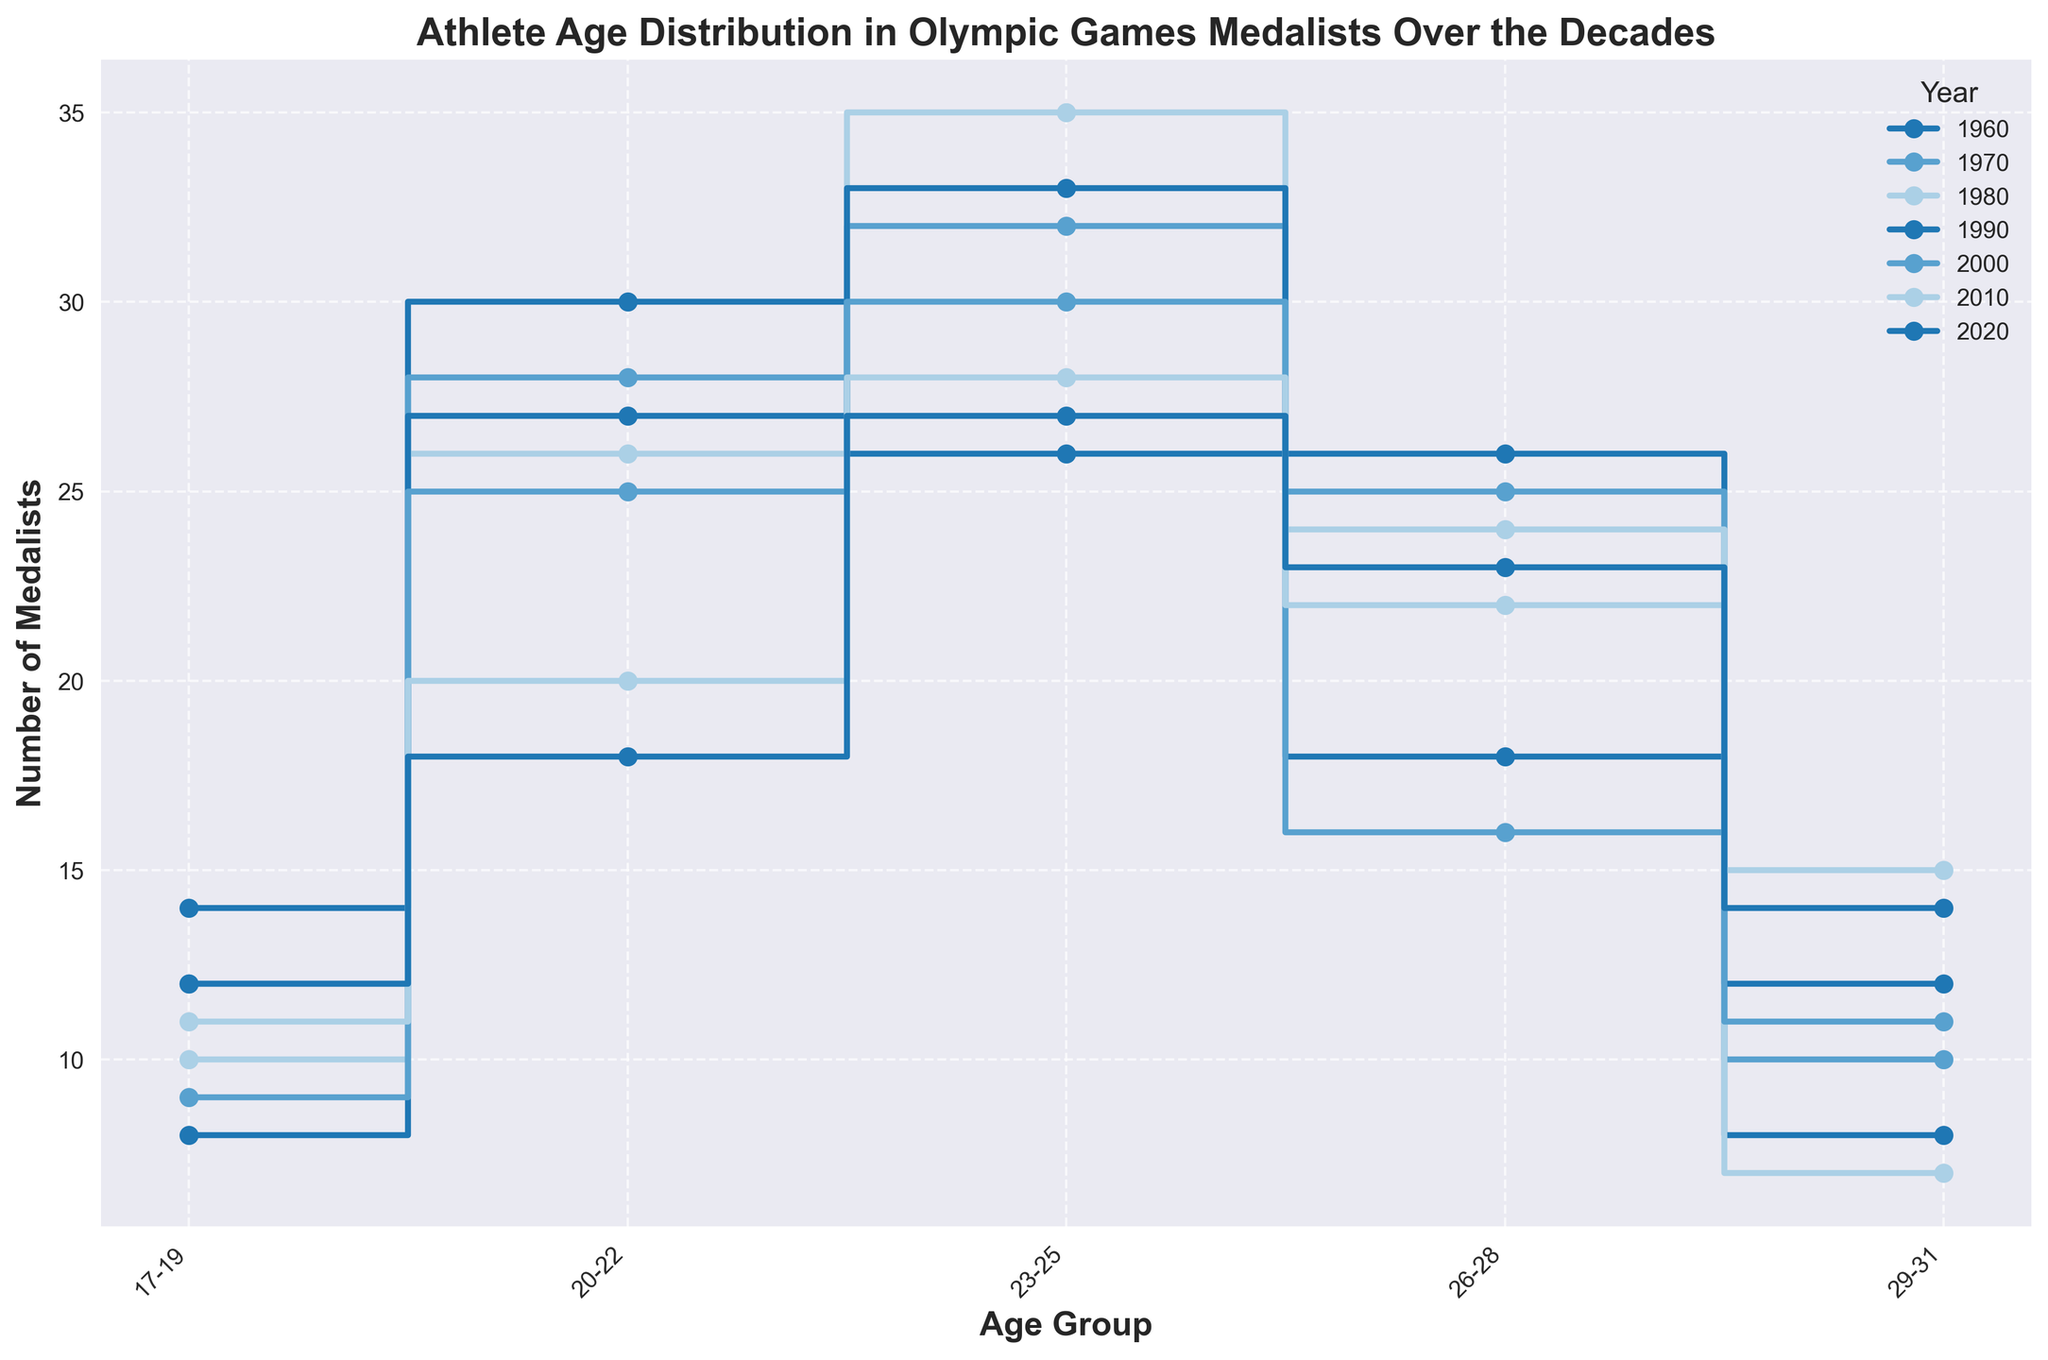How many age groups are shown on the x-axis? There are labels on the x-axis for different age groups. Count each unique label to find the number of age groups.
Answer: 5 What is the trend for the number of medalists in the 23-25 age group from 1960 to 2020? Observe the number of medalists in the 23-25 age group for each decade and see if it increases, decreases, or doesn't follow a specific pattern.
Answer: Generally increases Which year had the highest number of medalists in the 26-28 age group? Look at the height of the step plot point for each year at the 26-28 age group and identify the highest one.
Answer: 1980 What is the total number of medalists in the 29-31 age group for all the decades combined? Add the number of medalists in the 29-31 age group for each decade: 8 (1960) + 10 (1970) + 7 (1980) + 12 (1990) + 11 (2000) + 15 (2010) + 14 (2020) = 77
Answer: 77 Compare the number of medalists in the 17-19 age group in 1960 and 2020. Which year had more? Check the data points or steps for the 17-19 age group in 1960 and 2020. Compare the heights to see which is greater.
Answer: 1960 What pattern can be observed in the 20-22 age group across the decades? Observe the changes in the number of medalists in the 20-22 age group from 1960 to 2020. Look for increases, decreases, or other trends.
Answer: Generally decreases Which age group had the most consistent number of medalists over the decades? Look for the age group where the step plot lines show the least variation in height across all the decades.
Answer: 23-25 What is the difference in the number of medalists in the 26-28 age group between 1980 and 2010? Subtract the number of medalists in the 26-28 age group in 2010 from that in 1980: 22 (1980) - 24 (2010) = -2
Answer: -2 Identify the decade with the lowest number of total medalists in all age groups combined. Sum the medalist counts for each age group per decade and find the decade with the smallest sum.
Answer: 2010 How does the distribution of medalists in the 23-25 age group in 2020 compare to the other age groups in the same year? Compare the height of the step plot at the 23-25 age group in 2020 to the 17-19, 20-22, 26-28, and 29-31 age groups in the same year.
Answer: Highest 